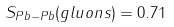<formula> <loc_0><loc_0><loc_500><loc_500>S _ { P b - P b } ( g l u o n s ) = 0 . 7 1</formula> 